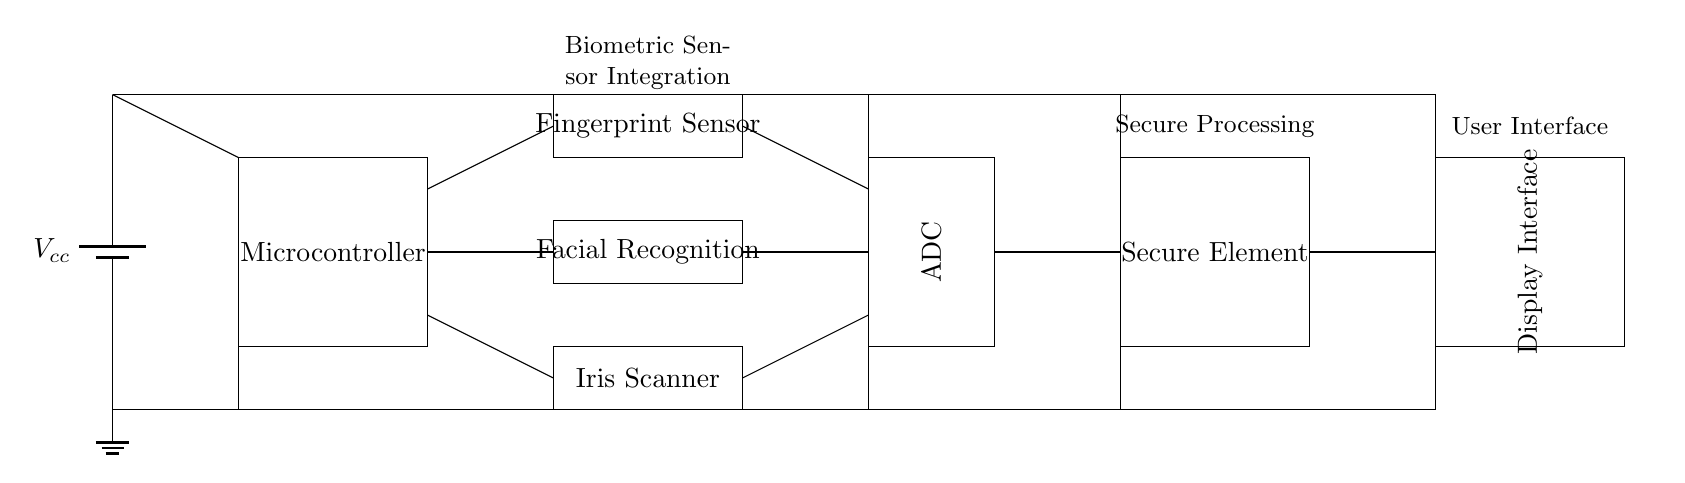What components are included in the biometric sensor integration? The circuit includes a microcontroller, fingerprint sensor, facial recognition camera, iris scanner, ADC, secure element, and display interface.
Answer: microcontroller, fingerprint sensor, facial recognition camera, iris scanner, ADC, secure element, display interface What is the purpose of the ADC in this circuit? The ADC converts the analog signals from the biometric sensors into digital signals for processing by the microcontroller.
Answer: Signal conversion How many biometric sensors are connected to the microcontroller? There are three biometric sensors connected to the microcontroller: fingerprint sensor, facial recognition camera, and iris scanner.
Answer: Three Which component directly connects to the display interface? The secure element is directly connected to the display interface.
Answer: Secure element What type of power source is used in this circuit? The circuit uses a battery as the power source for operating the components.
Answer: Battery Why is a secure element included in this circuit? The secure element is necessary for securely processing and storing sensitive biometric data, enhancing overall security.
Answer: Security processing What is the primary voltage supply for this circuit? The primary voltage supply for the circuit is denoted as Vcc, indicating a common power supply voltage level.
Answer: Vcc 